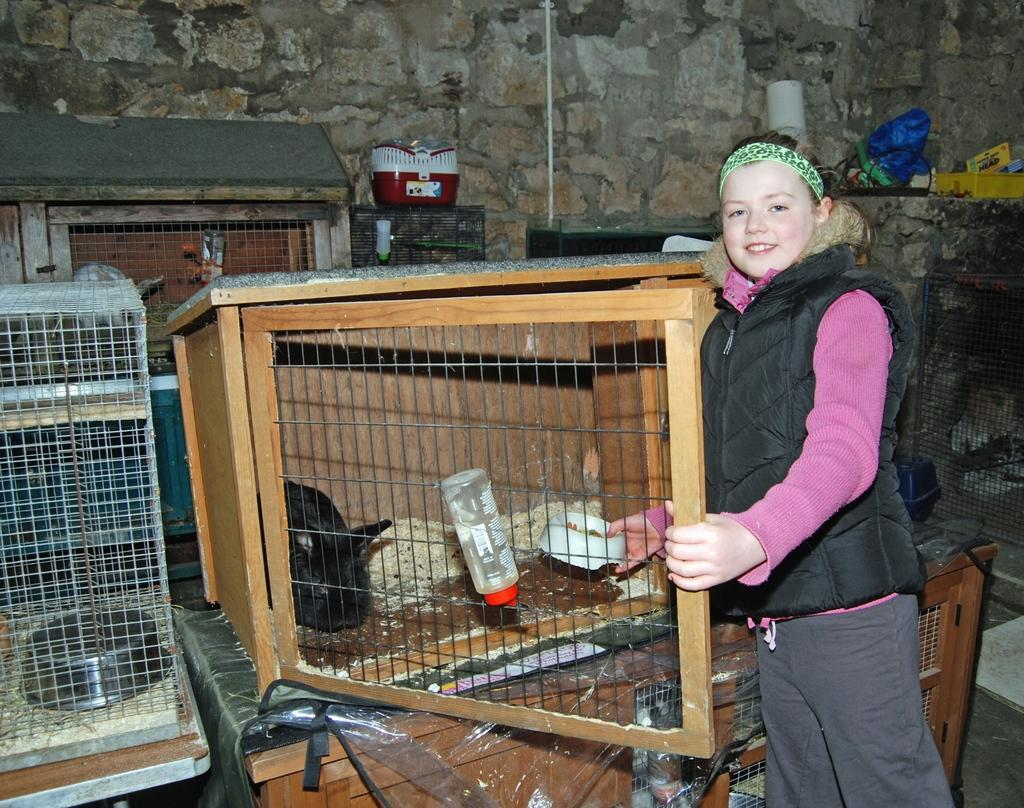What type of enclosures are present in the image? There are cages in the image. What can be found inside the cages? There is a rabbit in the image. What items are used for feeding the animals? There are bowls and a bottle in the image. What type of food is visible in the image? There are food items in the image. What is the background of the image made of? There is a wall in the image. Are there any other objects present in the image? Yes, there is a pipe and other objects in the image. Who is present in the foreground of the image? There is a kid standing in the foreground of the image. What is the kid's expression? The kid is smiling. What type of cream is being used to paint the structure in the image? There is no structure or cream present in the image. How many sacks are visible in the image? There are no sacks present in the image. 